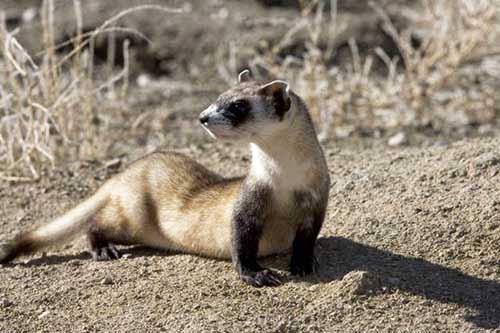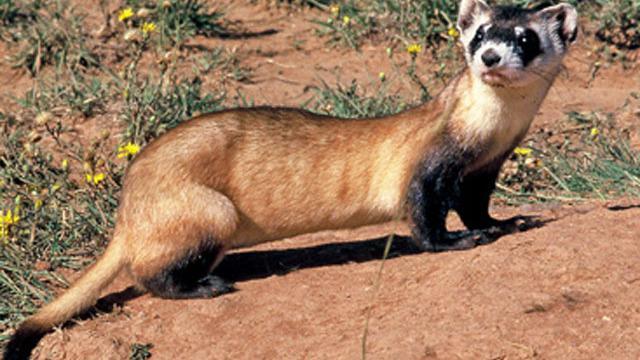The first image is the image on the left, the second image is the image on the right. Evaluate the accuracy of this statement regarding the images: "In one of the images there are 2 animals.". Is it true? Answer yes or no. No. 